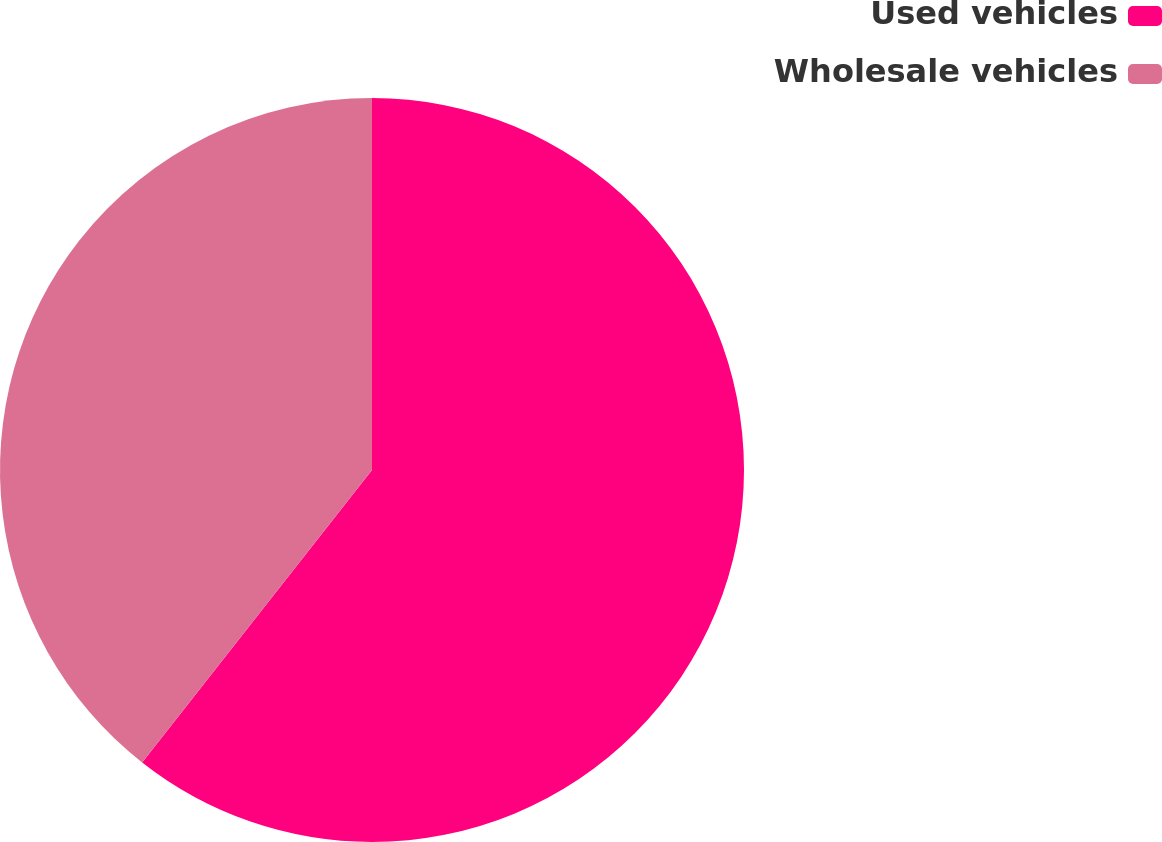<chart> <loc_0><loc_0><loc_500><loc_500><pie_chart><fcel>Used vehicles<fcel>Wholesale vehicles<nl><fcel>60.6%<fcel>39.4%<nl></chart> 